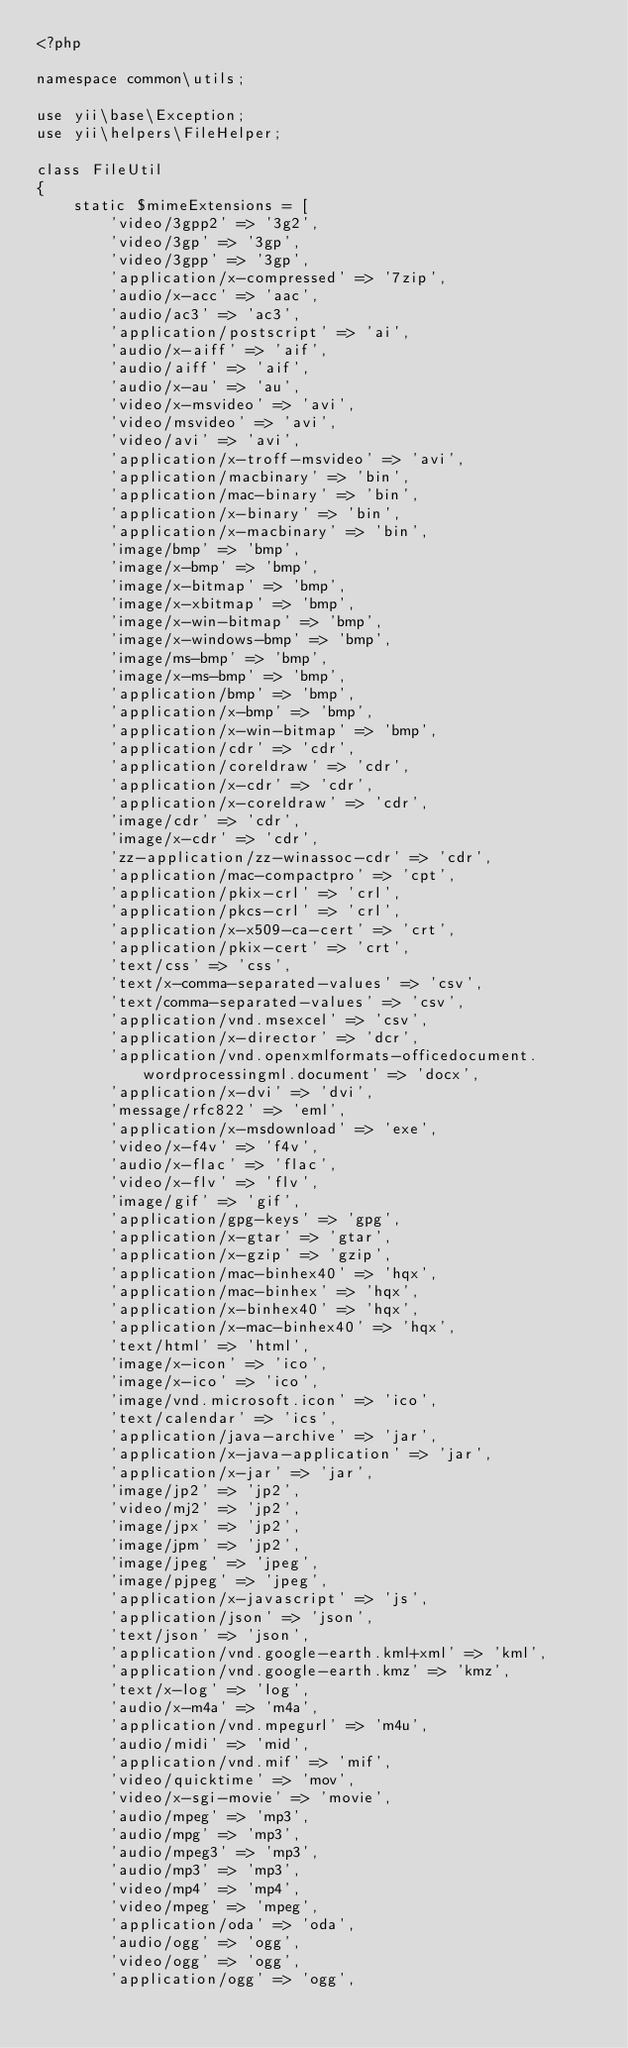<code> <loc_0><loc_0><loc_500><loc_500><_PHP_><?php

namespace common\utils;

use yii\base\Exception;
use yii\helpers\FileHelper;

class FileUtil
{
	static $mimeExtensions = [
		'video/3gpp2' => '3g2',
		'video/3gp' => '3gp',
		'video/3gpp' => '3gp',
		'application/x-compressed' => '7zip',
		'audio/x-acc' => 'aac',
		'audio/ac3' => 'ac3',
		'application/postscript' => 'ai',
		'audio/x-aiff' => 'aif',
		'audio/aiff' => 'aif',
		'audio/x-au' => 'au',
		'video/x-msvideo' => 'avi',
		'video/msvideo' => 'avi',
		'video/avi' => 'avi',
		'application/x-troff-msvideo' => 'avi',
		'application/macbinary' => 'bin',
		'application/mac-binary' => 'bin',
		'application/x-binary' => 'bin',
		'application/x-macbinary' => 'bin',
		'image/bmp' => 'bmp',
		'image/x-bmp' => 'bmp',
		'image/x-bitmap' => 'bmp',
		'image/x-xbitmap' => 'bmp',
		'image/x-win-bitmap' => 'bmp',
		'image/x-windows-bmp' => 'bmp',
		'image/ms-bmp' => 'bmp',
		'image/x-ms-bmp' => 'bmp',
		'application/bmp' => 'bmp',
		'application/x-bmp' => 'bmp',
		'application/x-win-bitmap' => 'bmp',
		'application/cdr' => 'cdr',
		'application/coreldraw' => 'cdr',
		'application/x-cdr' => 'cdr',
		'application/x-coreldraw' => 'cdr',
		'image/cdr' => 'cdr',
		'image/x-cdr' => 'cdr',
		'zz-application/zz-winassoc-cdr' => 'cdr',
		'application/mac-compactpro' => 'cpt',
		'application/pkix-crl' => 'crl',
		'application/pkcs-crl' => 'crl',
		'application/x-x509-ca-cert' => 'crt',
		'application/pkix-cert' => 'crt',
		'text/css' => 'css',
		'text/x-comma-separated-values' => 'csv',
		'text/comma-separated-values' => 'csv',
		'application/vnd.msexcel' => 'csv',
		'application/x-director' => 'dcr',
		'application/vnd.openxmlformats-officedocument.wordprocessingml.document' => 'docx',
		'application/x-dvi' => 'dvi',
		'message/rfc822' => 'eml',
		'application/x-msdownload' => 'exe',
		'video/x-f4v' => 'f4v',
		'audio/x-flac' => 'flac',
		'video/x-flv' => 'flv',
		'image/gif' => 'gif',
		'application/gpg-keys' => 'gpg',
		'application/x-gtar' => 'gtar',
		'application/x-gzip' => 'gzip',
		'application/mac-binhex40' => 'hqx',
		'application/mac-binhex' => 'hqx',
		'application/x-binhex40' => 'hqx',
		'application/x-mac-binhex40' => 'hqx',
		'text/html' => 'html',
		'image/x-icon' => 'ico',
		'image/x-ico' => 'ico',
		'image/vnd.microsoft.icon' => 'ico',
		'text/calendar' => 'ics',
		'application/java-archive' => 'jar',
		'application/x-java-application' => 'jar',
		'application/x-jar' => 'jar',
		'image/jp2' => 'jp2',
		'video/mj2' => 'jp2',
		'image/jpx' => 'jp2',
		'image/jpm' => 'jp2',
		'image/jpeg' => 'jpeg',
		'image/pjpeg' => 'jpeg',
		'application/x-javascript' => 'js',
		'application/json' => 'json',
		'text/json' => 'json',
		'application/vnd.google-earth.kml+xml' => 'kml',
		'application/vnd.google-earth.kmz' => 'kmz',
		'text/x-log' => 'log',
		'audio/x-m4a' => 'm4a',
		'application/vnd.mpegurl' => 'm4u',
		'audio/midi' => 'mid',
		'application/vnd.mif' => 'mif',
		'video/quicktime' => 'mov',
		'video/x-sgi-movie' => 'movie',
		'audio/mpeg' => 'mp3',
		'audio/mpg' => 'mp3',
		'audio/mpeg3' => 'mp3',
		'audio/mp3' => 'mp3',
		'video/mp4' => 'mp4',
		'video/mpeg' => 'mpeg',
		'application/oda' => 'oda',
		'audio/ogg' => 'ogg',
		'video/ogg' => 'ogg',
		'application/ogg' => 'ogg',</code> 